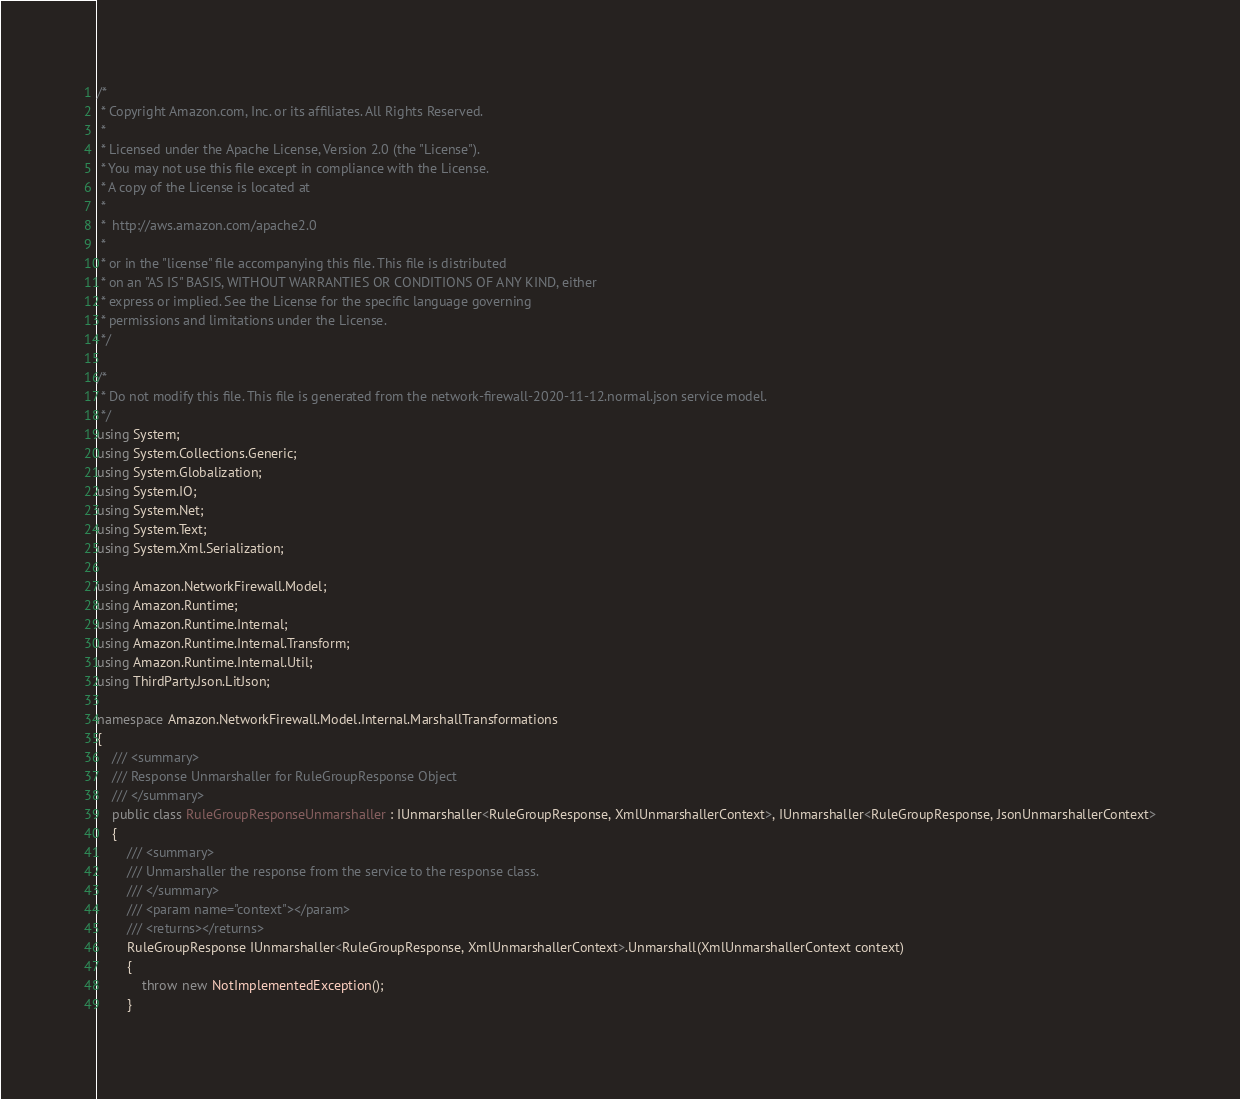Convert code to text. <code><loc_0><loc_0><loc_500><loc_500><_C#_>/*
 * Copyright Amazon.com, Inc. or its affiliates. All Rights Reserved.
 * 
 * Licensed under the Apache License, Version 2.0 (the "License").
 * You may not use this file except in compliance with the License.
 * A copy of the License is located at
 * 
 *  http://aws.amazon.com/apache2.0
 * 
 * or in the "license" file accompanying this file. This file is distributed
 * on an "AS IS" BASIS, WITHOUT WARRANTIES OR CONDITIONS OF ANY KIND, either
 * express or implied. See the License for the specific language governing
 * permissions and limitations under the License.
 */

/*
 * Do not modify this file. This file is generated from the network-firewall-2020-11-12.normal.json service model.
 */
using System;
using System.Collections.Generic;
using System.Globalization;
using System.IO;
using System.Net;
using System.Text;
using System.Xml.Serialization;

using Amazon.NetworkFirewall.Model;
using Amazon.Runtime;
using Amazon.Runtime.Internal;
using Amazon.Runtime.Internal.Transform;
using Amazon.Runtime.Internal.Util;
using ThirdParty.Json.LitJson;

namespace Amazon.NetworkFirewall.Model.Internal.MarshallTransformations
{
    /// <summary>
    /// Response Unmarshaller for RuleGroupResponse Object
    /// </summary>  
    public class RuleGroupResponseUnmarshaller : IUnmarshaller<RuleGroupResponse, XmlUnmarshallerContext>, IUnmarshaller<RuleGroupResponse, JsonUnmarshallerContext>
    {
        /// <summary>
        /// Unmarshaller the response from the service to the response class.
        /// </summary>  
        /// <param name="context"></param>
        /// <returns></returns>
        RuleGroupResponse IUnmarshaller<RuleGroupResponse, XmlUnmarshallerContext>.Unmarshall(XmlUnmarshallerContext context)
        {
            throw new NotImplementedException();
        }
</code> 